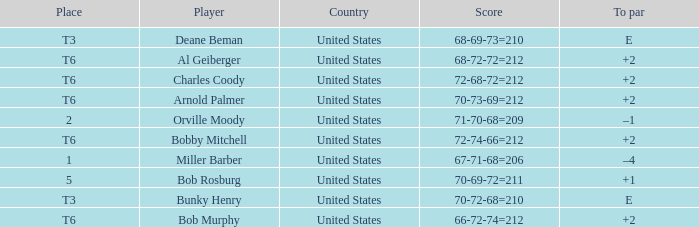What is the score of player bob rosburg? 70-69-72=211. 